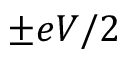<formula> <loc_0><loc_0><loc_500><loc_500>\pm e V / 2</formula> 